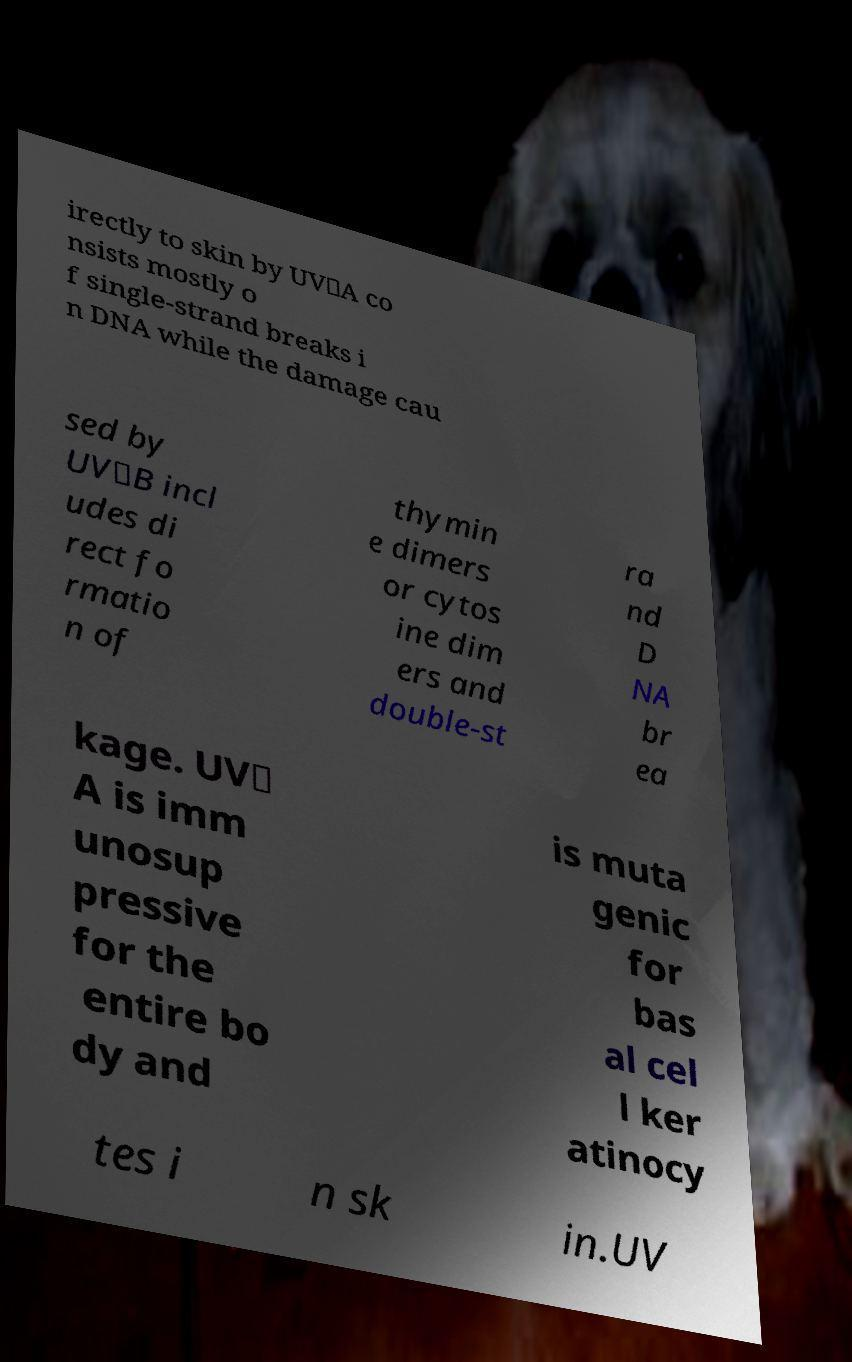What messages or text are displayed in this image? I need them in a readable, typed format. irectly to skin by UV‑A co nsists mostly o f single-strand breaks i n DNA while the damage cau sed by UV‑B incl udes di rect fo rmatio n of thymin e dimers or cytos ine dim ers and double-st ra nd D NA br ea kage. UV‑ A is imm unosup pressive for the entire bo dy and is muta genic for bas al cel l ker atinocy tes i n sk in.UV 